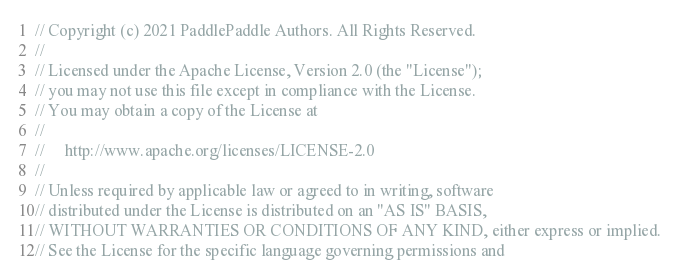Convert code to text. <code><loc_0><loc_0><loc_500><loc_500><_Cuda_>// Copyright (c) 2021 PaddlePaddle Authors. All Rights Reserved.
//
// Licensed under the Apache License, Version 2.0 (the "License");
// you may not use this file except in compliance with the License.
// You may obtain a copy of the License at
//
//     http://www.apache.org/licenses/LICENSE-2.0
//
// Unless required by applicable law or agreed to in writing, software
// distributed under the License is distributed on an "AS IS" BASIS,
// WITHOUT WARRANTIES OR CONDITIONS OF ANY KIND, either express or implied.
// See the License for the specific language governing permissions and</code> 